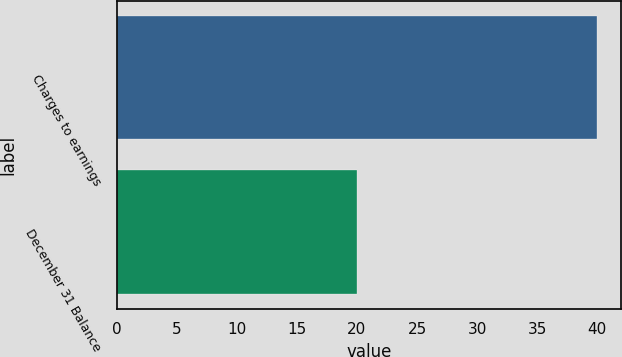Convert chart. <chart><loc_0><loc_0><loc_500><loc_500><bar_chart><fcel>Charges to earnings<fcel>December 31 Balance<nl><fcel>40<fcel>20<nl></chart> 